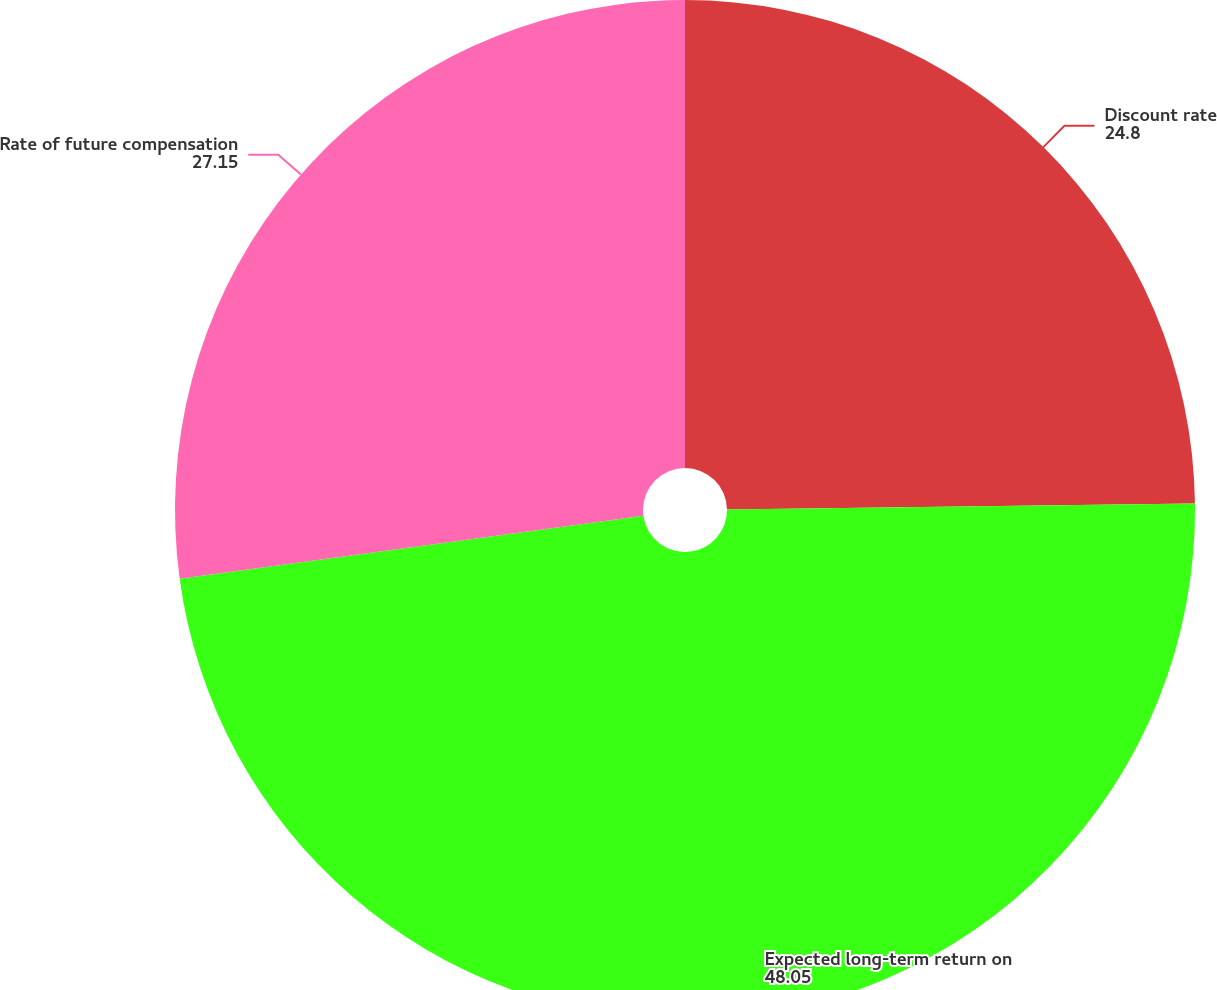Convert chart. <chart><loc_0><loc_0><loc_500><loc_500><pie_chart><fcel>Discount rate<fcel>Expected long-term return on<fcel>Rate of future compensation<nl><fcel>24.8%<fcel>48.05%<fcel>27.15%<nl></chart> 